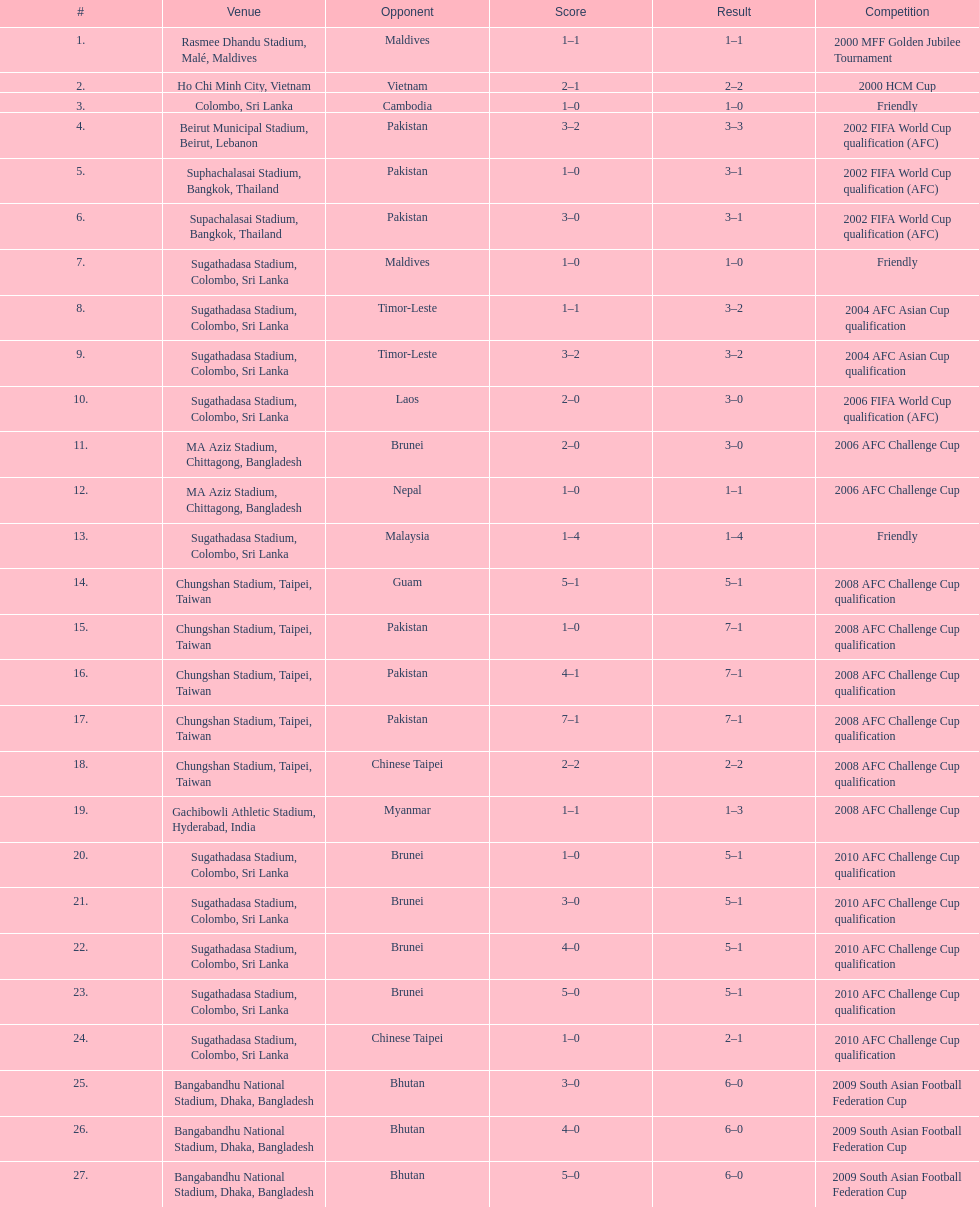In how many games did sri lanka score at least 2 goals? 16. 